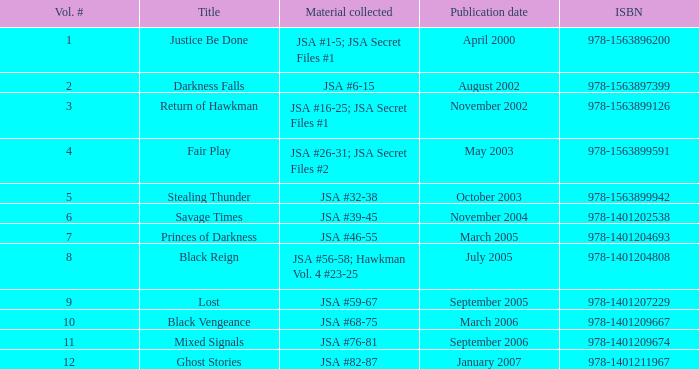What's the Material collected for the 978-1401209674 ISBN? JSA #76-81. 